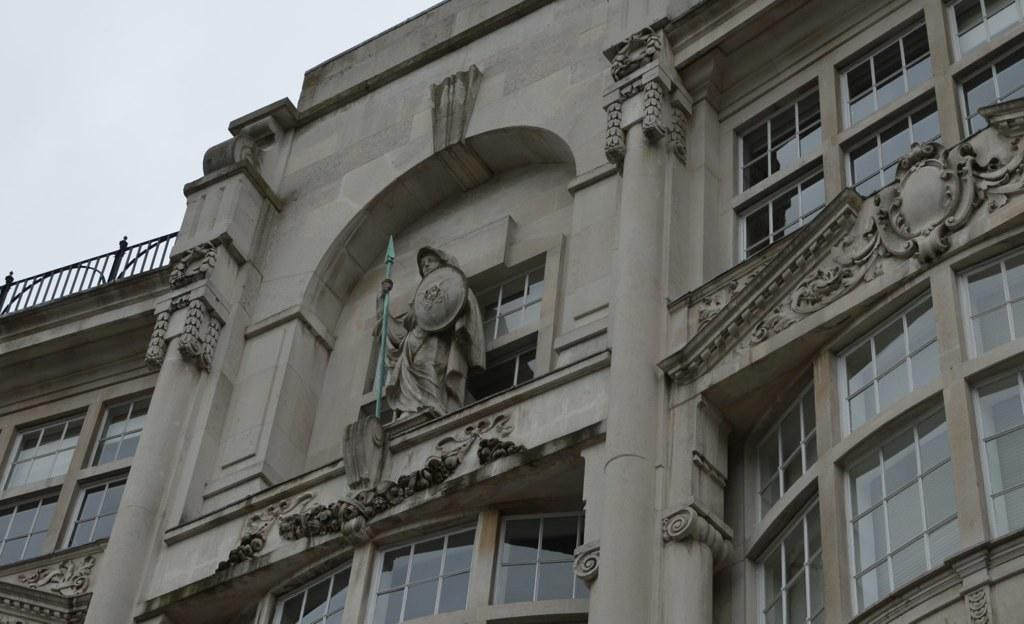What type of structure is present in the image? There is a building in the image. What can be seen in the middle of the image? There is a sculpture in the middle of the image. What part of the sky is visible in the image? The sky is visible in the top left of the image. How many goldfish are swimming around the sculpture in the image? There are no goldfish present in the image; it features a building and a sculpture. Can you describe the grandfather's expression as he looks at the sculpture in the image? There is no grandfather present in the image; it only features a building and a sculpture. 